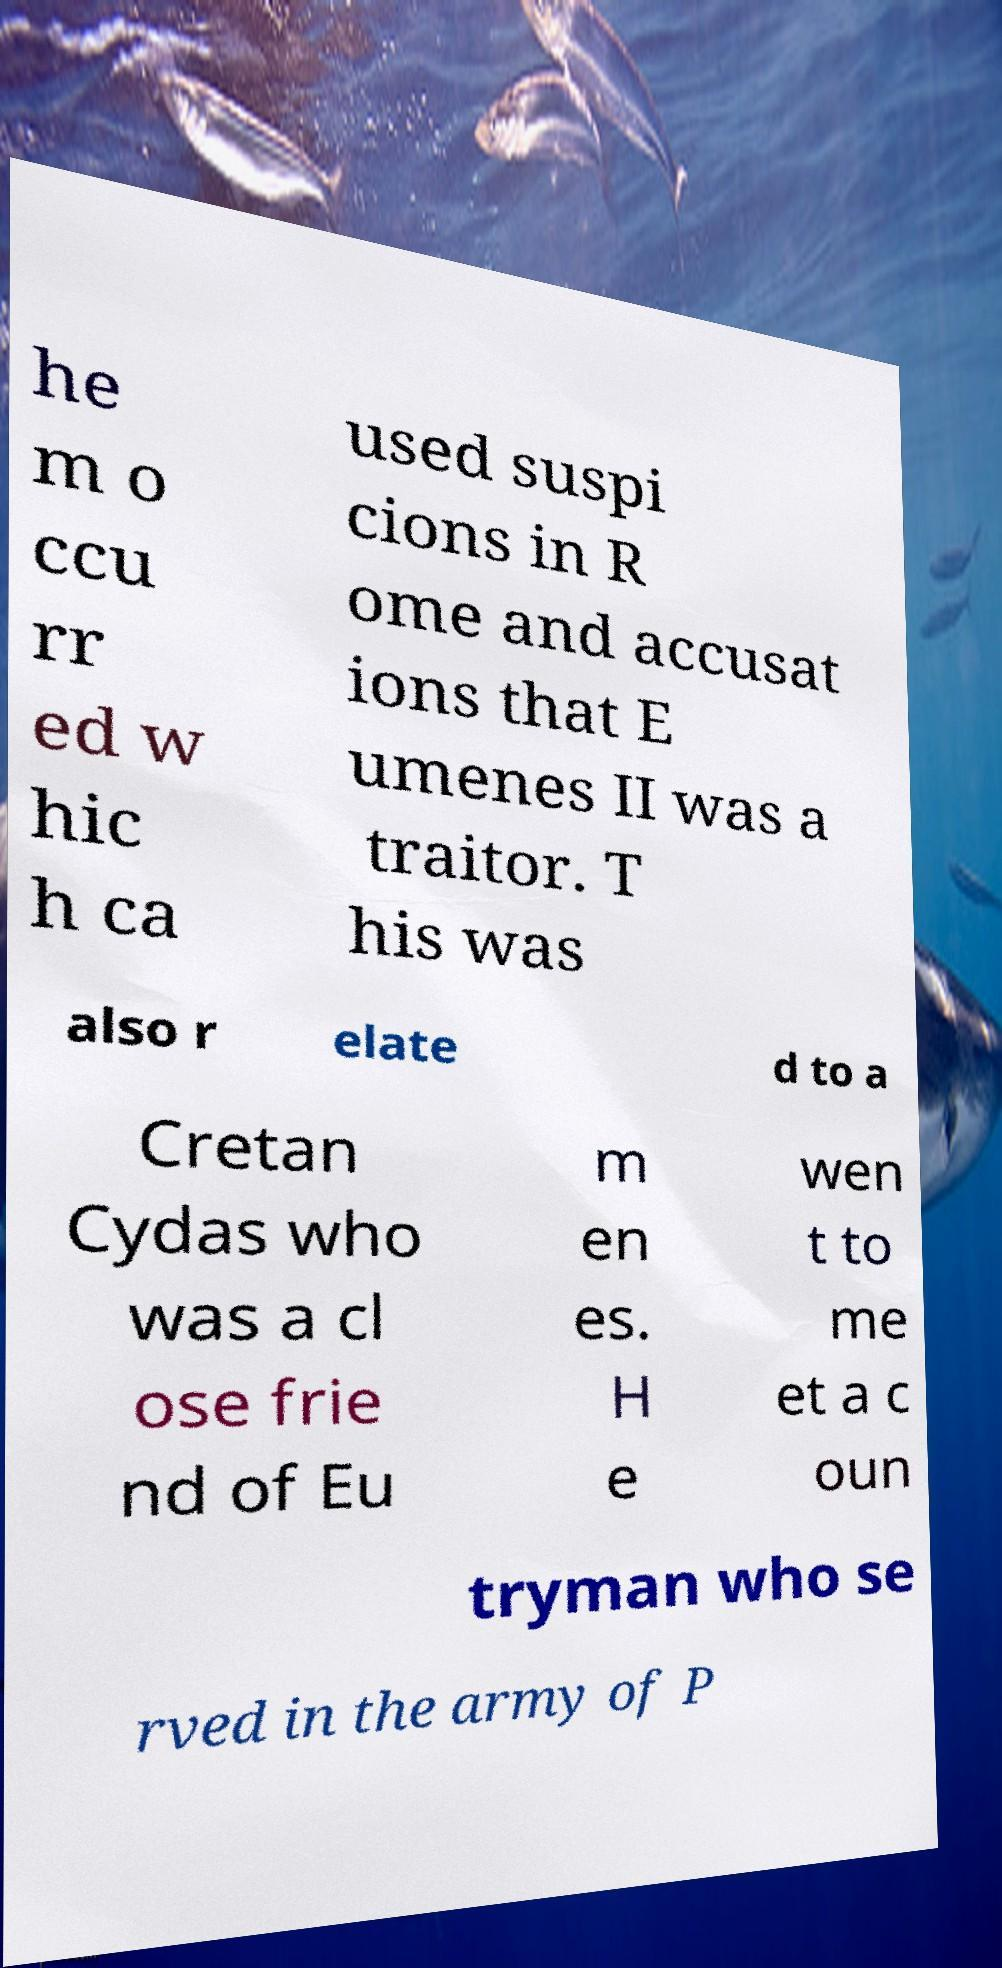For documentation purposes, I need the text within this image transcribed. Could you provide that? he m o ccu rr ed w hic h ca used suspi cions in R ome and accusat ions that E umenes II was a traitor. T his was also r elate d to a Cretan Cydas who was a cl ose frie nd of Eu m en es. H e wen t to me et a c oun tryman who se rved in the army of P 